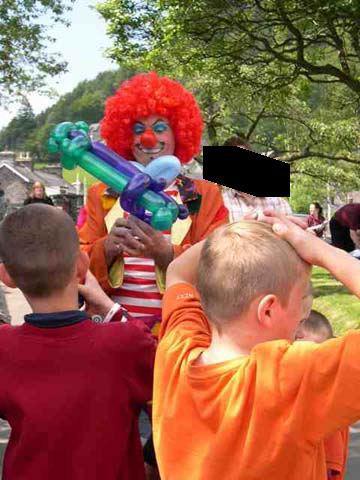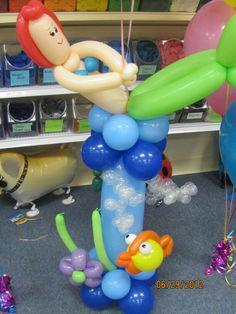The first image is the image on the left, the second image is the image on the right. Evaluate the accuracy of this statement regarding the images: "The right image includes a balloon animal face with small round ears and white balloon eyeballs.". Is it true? Answer yes or no. No. The first image is the image on the left, the second image is the image on the right. For the images shown, is this caption "Exactly one image contains a balloon animal with eyes." true? Answer yes or no. Yes. 